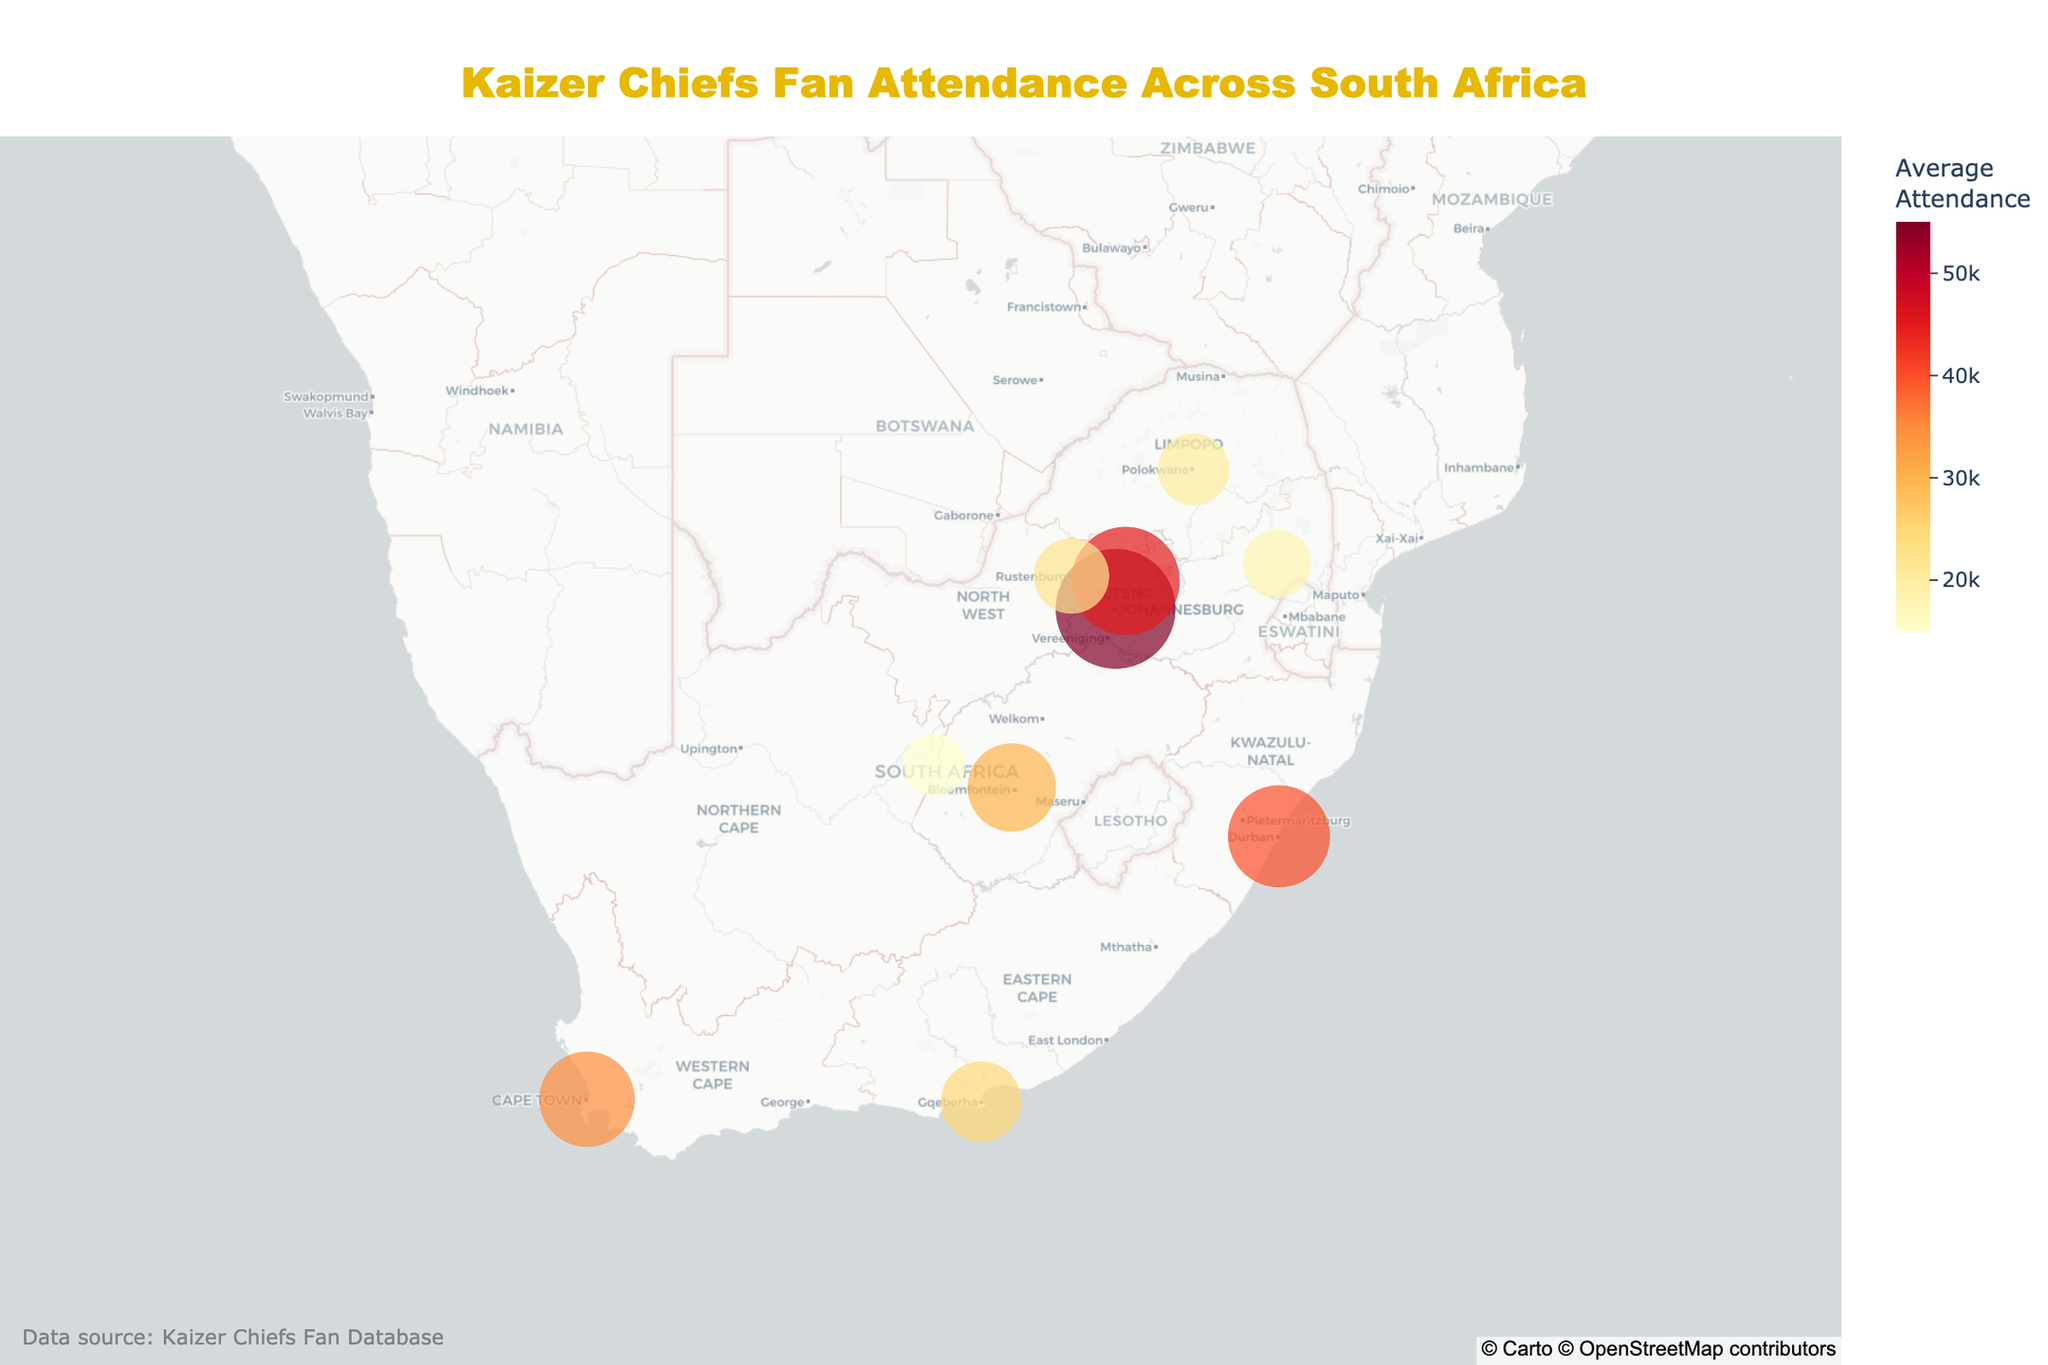How many cities are represented in the plot? Count the number of unique cities mentioned in the data. There are 10 cities listed.
Answer: 10 Which city has the highest average attendance? Look at the city with the largest circle and highest average attendance color. Johannesburg has the highest average attendance with 55,000.
Answer: Johannesburg What is the average attendance in Pretoria? Find Pretoria on the map and read the value from the hover data, which is 45,000.
Answer: 45,000 Compare average attendance in Durban and Cape Town. Are they equal? Identify the values for both cities from the hover data. Durban has 40,000 and Cape Town has 35,000; they are not equal.
Answer: No Which province has two cities with the highest average attendance? Check the provinces for the top cities. Gauteng has both Johannesburg (55,000) and Pretoria (45,000).
Answer: Gauteng What is the combined average attendance for Nelspruit and Rustenburg? Add the average attendance values for Nelspruit (18,000) and Rustenburg (22,000): 18,000 + 22,000 = 40,000.
Answer: 40,000 Which city has the lowest average attendance? Identify the city with the smallest circle and lowest color value. Kimberley with an average attendance of 15,000.
Answer: Kimberley How does the average attendance in Port Elizabeth compare to Polokwane? Port Elizabeth has 25,000 and Polokwane has 20,000, so Port Elizabeth has higher average attendance.
Answer: Port Elizabeth What is the median average attendance value of all the cities? List all attendances: 55,000, 45,000, 40,000, 35,000, 30,000, 25,000, 22,000, 20,000, 18,000, 15,000. The median is the middle value when sorted: 27,500.
Answer: 27,500 What color scale is used in the plot? The color scale used is mentioned in the code: px.colors.sequential.YlOrRd which shows light yellow to red.
Answer: YlOrRd 